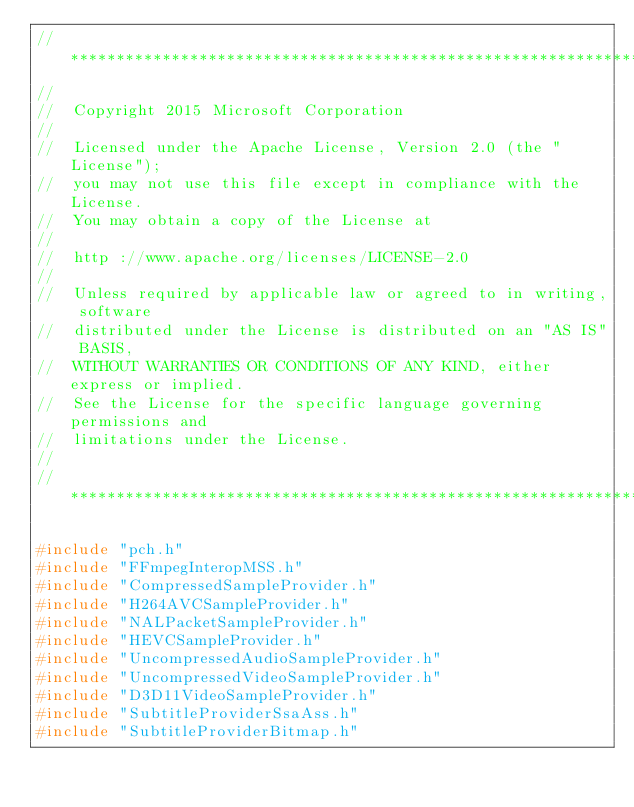<code> <loc_0><loc_0><loc_500><loc_500><_C++_>//*****************************************************************************
//
//	Copyright 2015 Microsoft Corporation
//
//	Licensed under the Apache License, Version 2.0 (the "License");
//	you may not use this file except in compliance with the License.
//	You may obtain a copy of the License at
//
//	http ://www.apache.org/licenses/LICENSE-2.0
//
//	Unless required by applicable law or agreed to in writing, software
//	distributed under the License is distributed on an "AS IS" BASIS,
//	WITHOUT WARRANTIES OR CONDITIONS OF ANY KIND, either express or implied.
//	See the License for the specific language governing permissions and
//	limitations under the License.
//
//*****************************************************************************

#include "pch.h"
#include "FFmpegInteropMSS.h"
#include "CompressedSampleProvider.h"
#include "H264AVCSampleProvider.h"
#include "NALPacketSampleProvider.h"
#include "HEVCSampleProvider.h"
#include "UncompressedAudioSampleProvider.h"
#include "UncompressedVideoSampleProvider.h"
#include "D3D11VideoSampleProvider.h"
#include "SubtitleProviderSsaAss.h"
#include "SubtitleProviderBitmap.h"</code> 